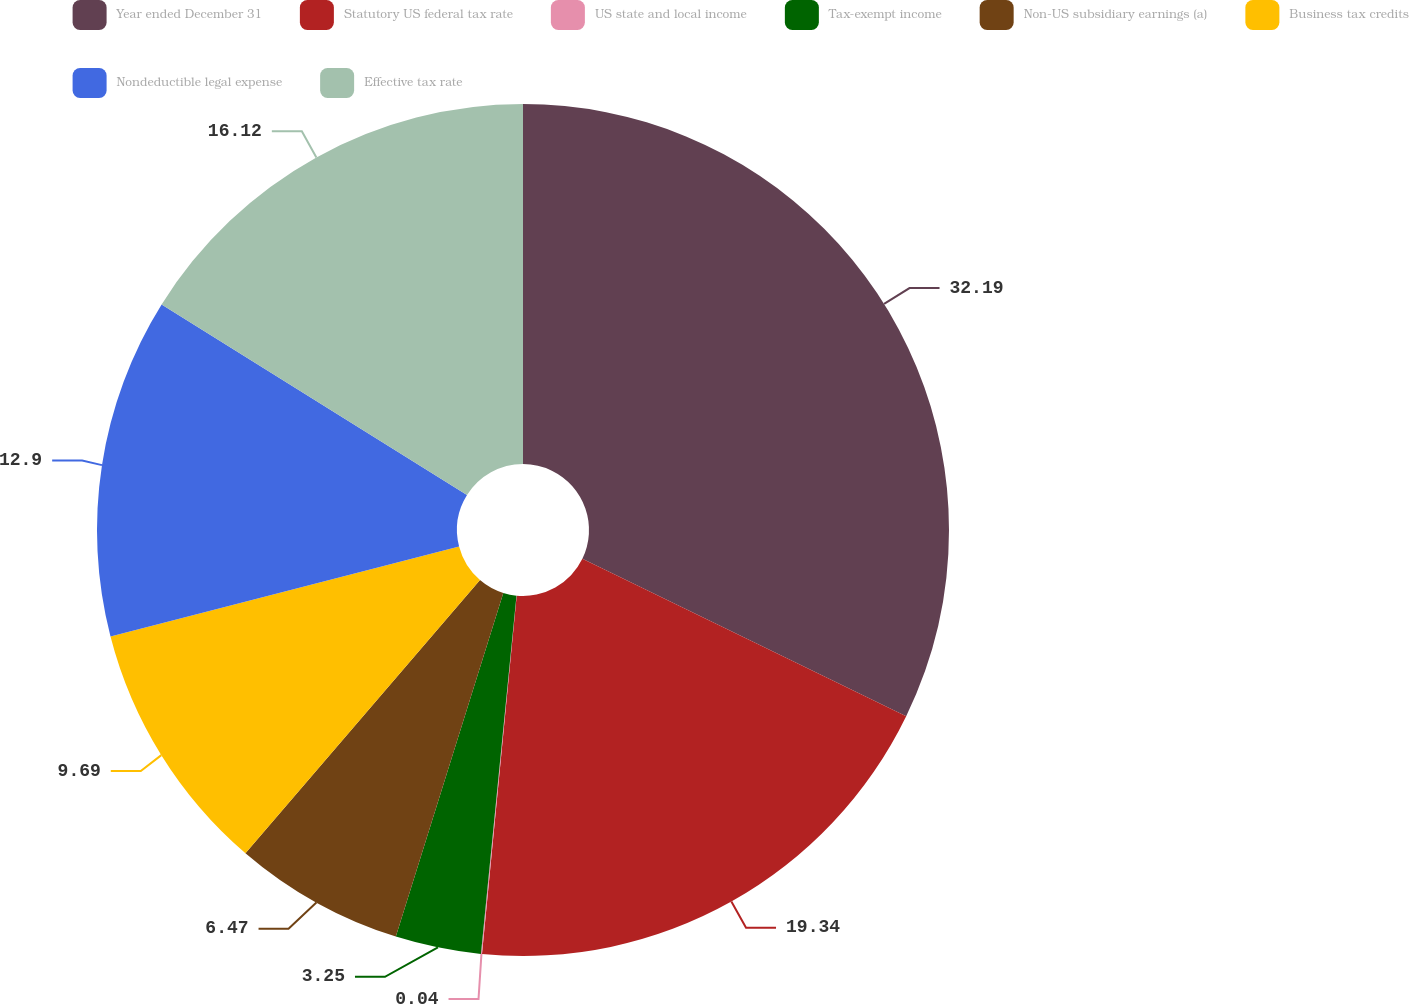Convert chart to OTSL. <chart><loc_0><loc_0><loc_500><loc_500><pie_chart><fcel>Year ended December 31<fcel>Statutory US federal tax rate<fcel>US state and local income<fcel>Tax-exempt income<fcel>Non-US subsidiary earnings (a)<fcel>Business tax credits<fcel>Nondeductible legal expense<fcel>Effective tax rate<nl><fcel>32.2%<fcel>19.34%<fcel>0.04%<fcel>3.25%<fcel>6.47%<fcel>9.69%<fcel>12.9%<fcel>16.12%<nl></chart> 